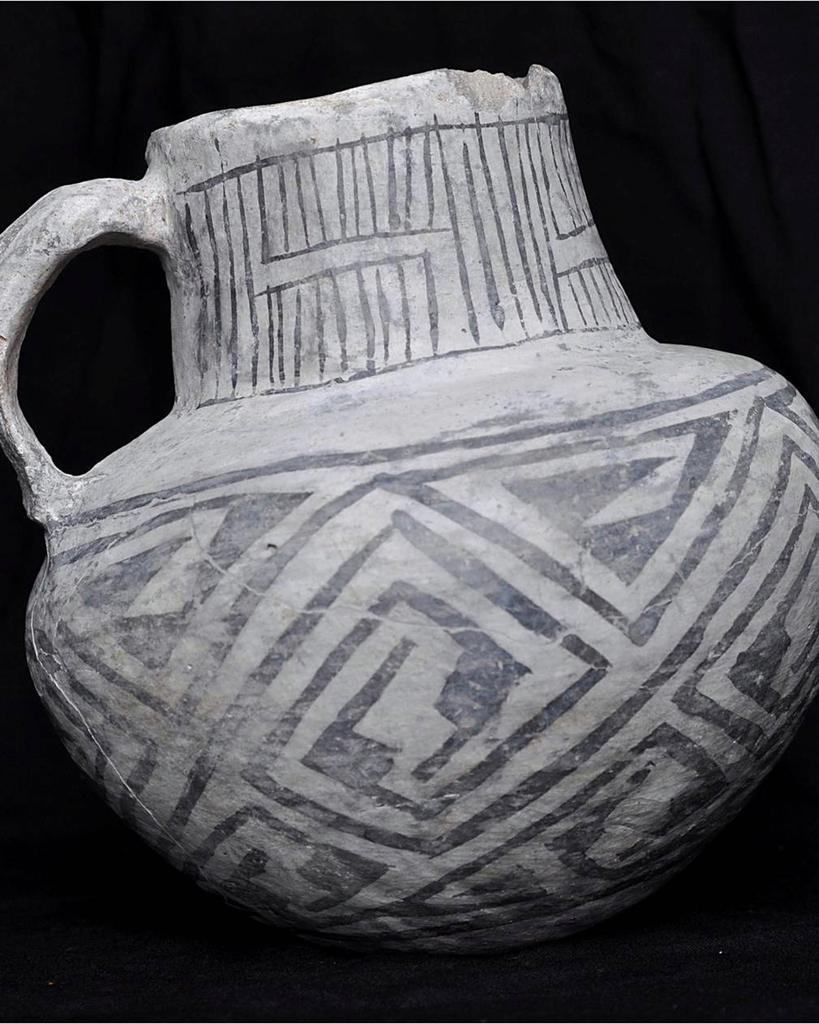Can you describe this image briefly? In this picture I can observe stoneware. The background is completely dark. 